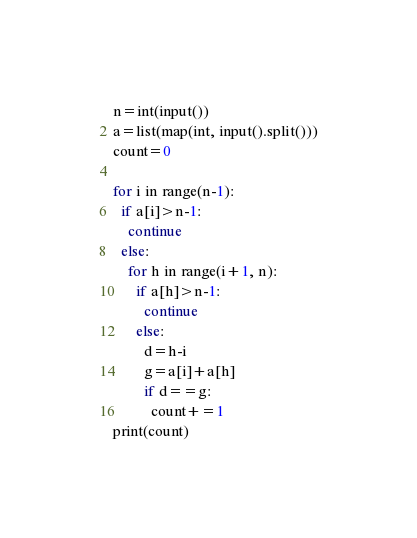Convert code to text. <code><loc_0><loc_0><loc_500><loc_500><_Python_>n=int(input())
a=list(map(int, input().split()))
count=0

for i in range(n-1):
  if a[i]>n-1:
    continue
  else:
    for h in range(i+1, n):
      if a[h]>n-1:
        continue    
      else:
        d=h-i
        g=a[i]+a[h]
        if d==g:
          count+=1
print(count)
</code> 